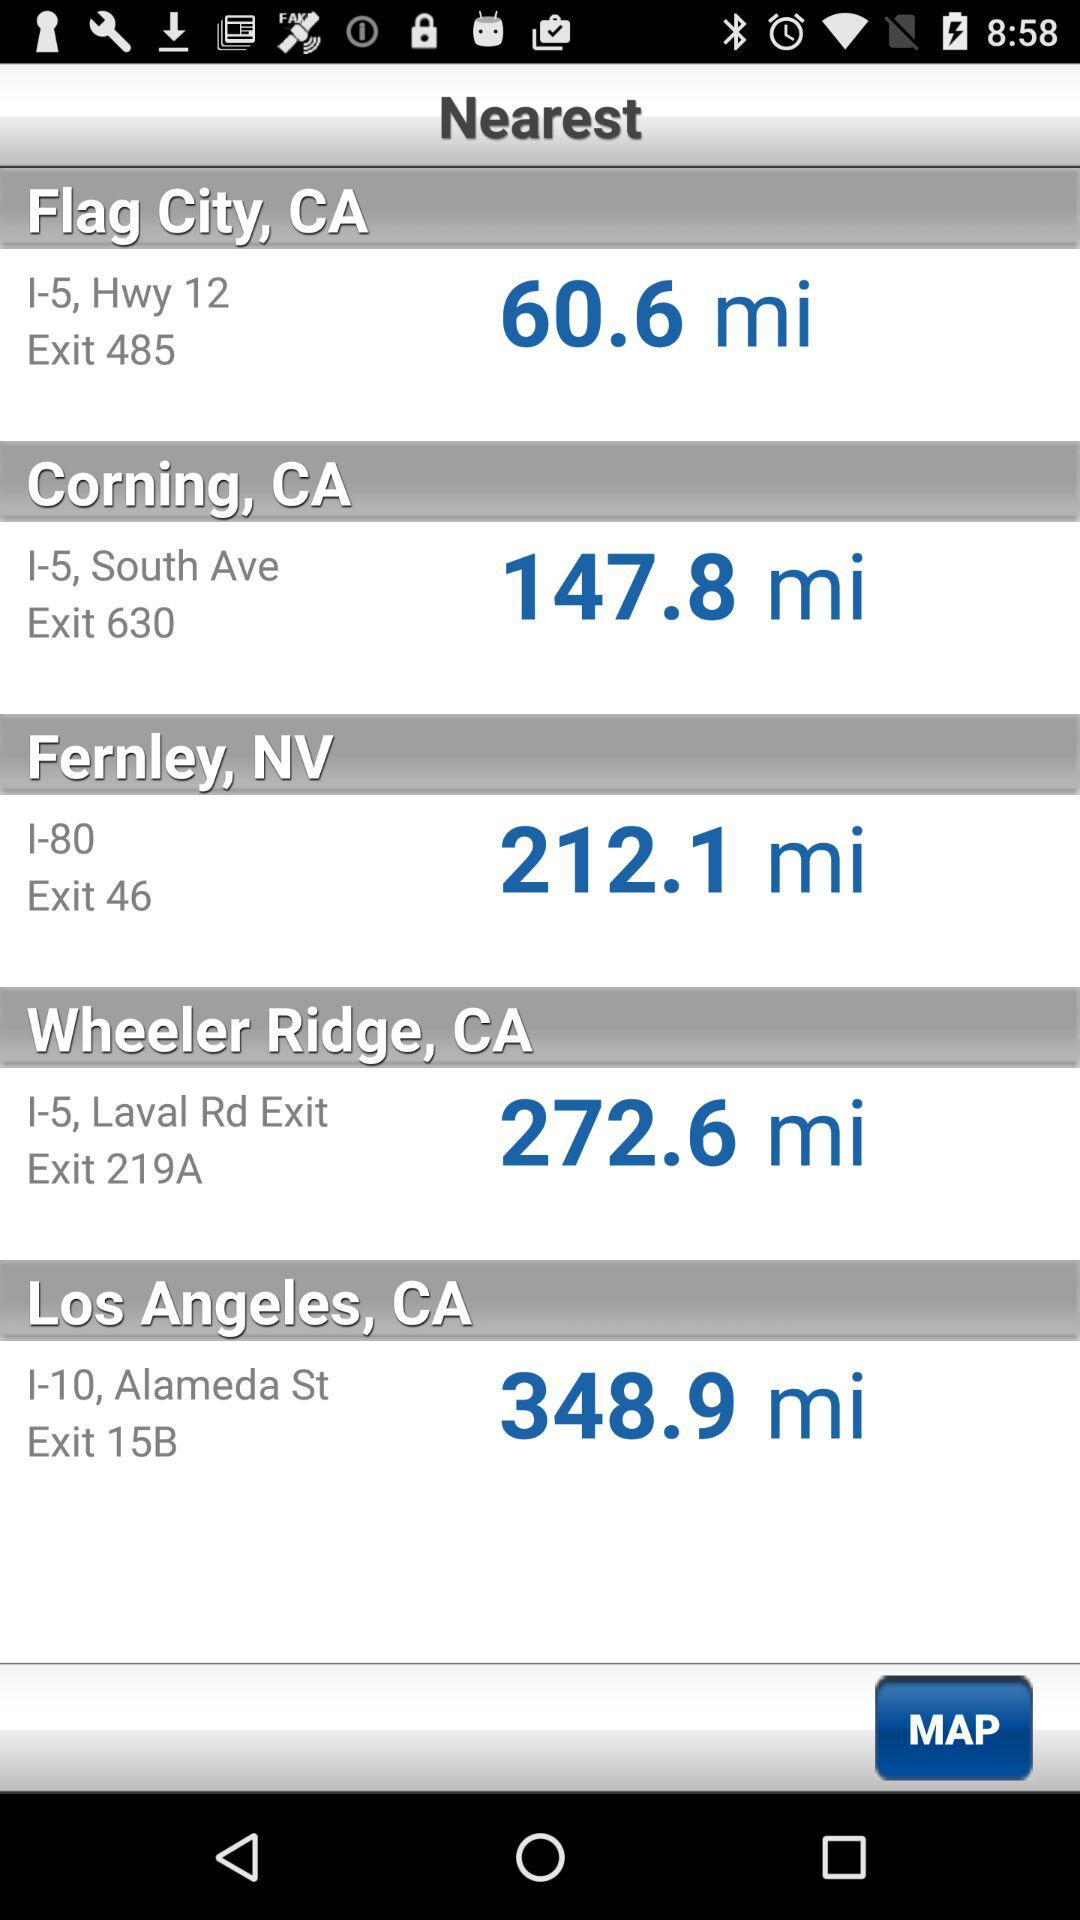What is the exit for Flag City? The exit for Flag City is 485. 